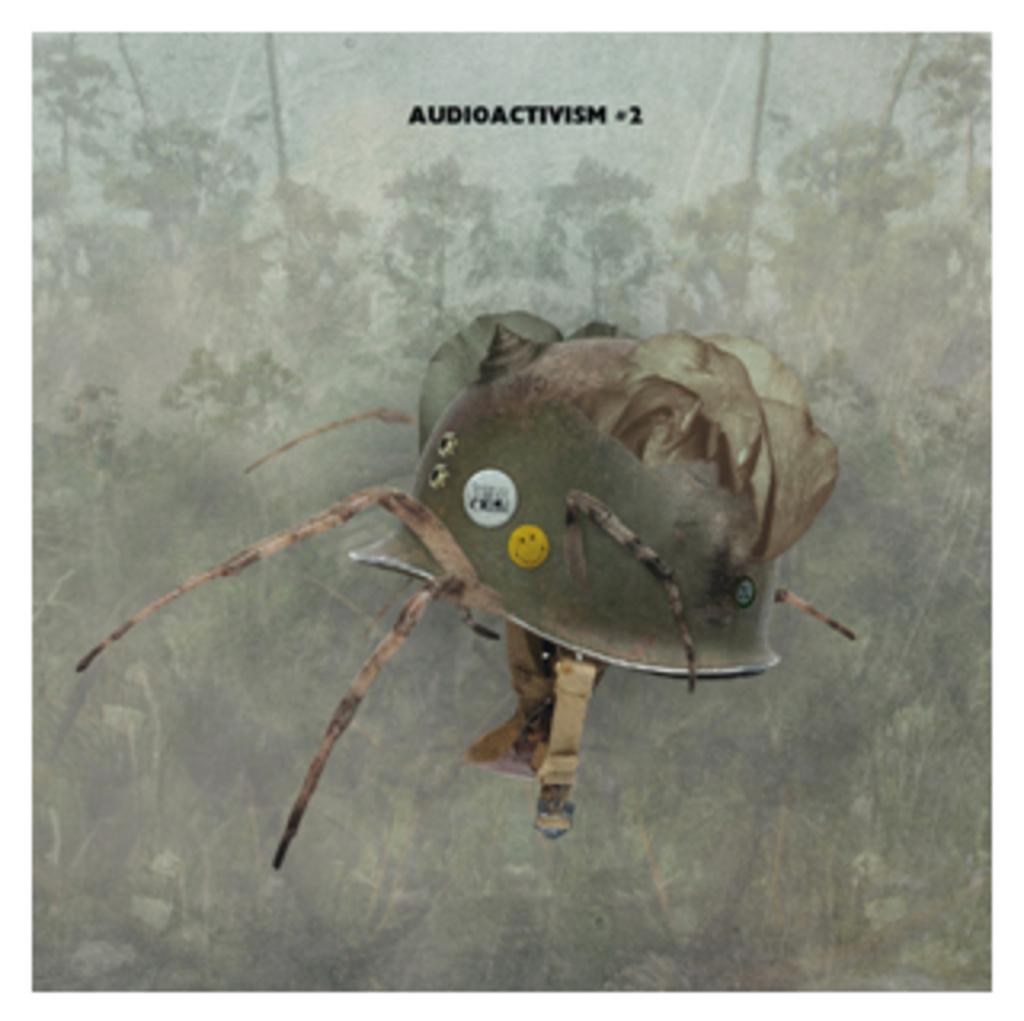Describe this image in one or two sentences. This looks like an edited image. I think this is a helmet. In the background, I can see the trees and plants. This is the watermark on the image. 